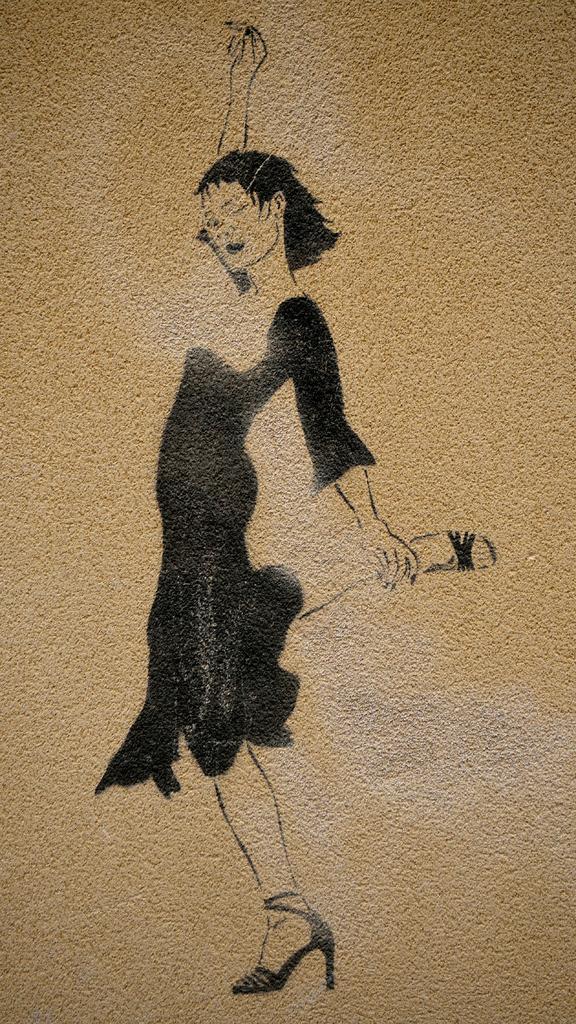In one or two sentences, can you explain what this image depicts? In this picture we can see a painting of a woman on a surface and this woman wore sandals and standing. 